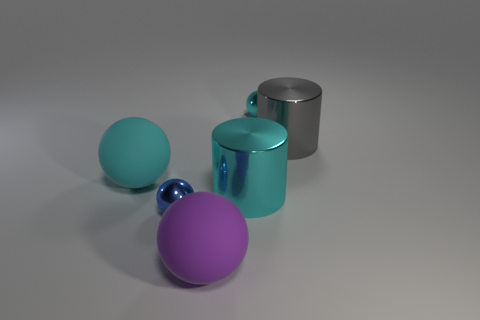Does the object that is on the right side of the tiny cyan metallic ball have the same shape as the large cyan matte object?
Give a very brief answer. No. What color is the other matte object that is the same shape as the purple matte thing?
Offer a very short reply. Cyan. Is there anything else that has the same shape as the blue thing?
Make the answer very short. Yes. Are there the same number of big rubber balls in front of the large gray shiny cylinder and tiny cyan balls?
Your answer should be very brief. No. What number of big things are both behind the big purple matte ball and to the right of the blue sphere?
Offer a very short reply. 2. There is a blue thing that is the same shape as the large cyan rubber thing; what size is it?
Keep it short and to the point. Small. How many small cyan spheres are the same material as the small blue object?
Offer a very short reply. 1. Are there fewer cylinders that are to the left of the tiny blue object than large gray cylinders?
Offer a very short reply. Yes. How many blue shiny balls are there?
Provide a short and direct response. 1. Is the shape of the large cyan metallic object the same as the gray metallic thing?
Offer a terse response. Yes. 